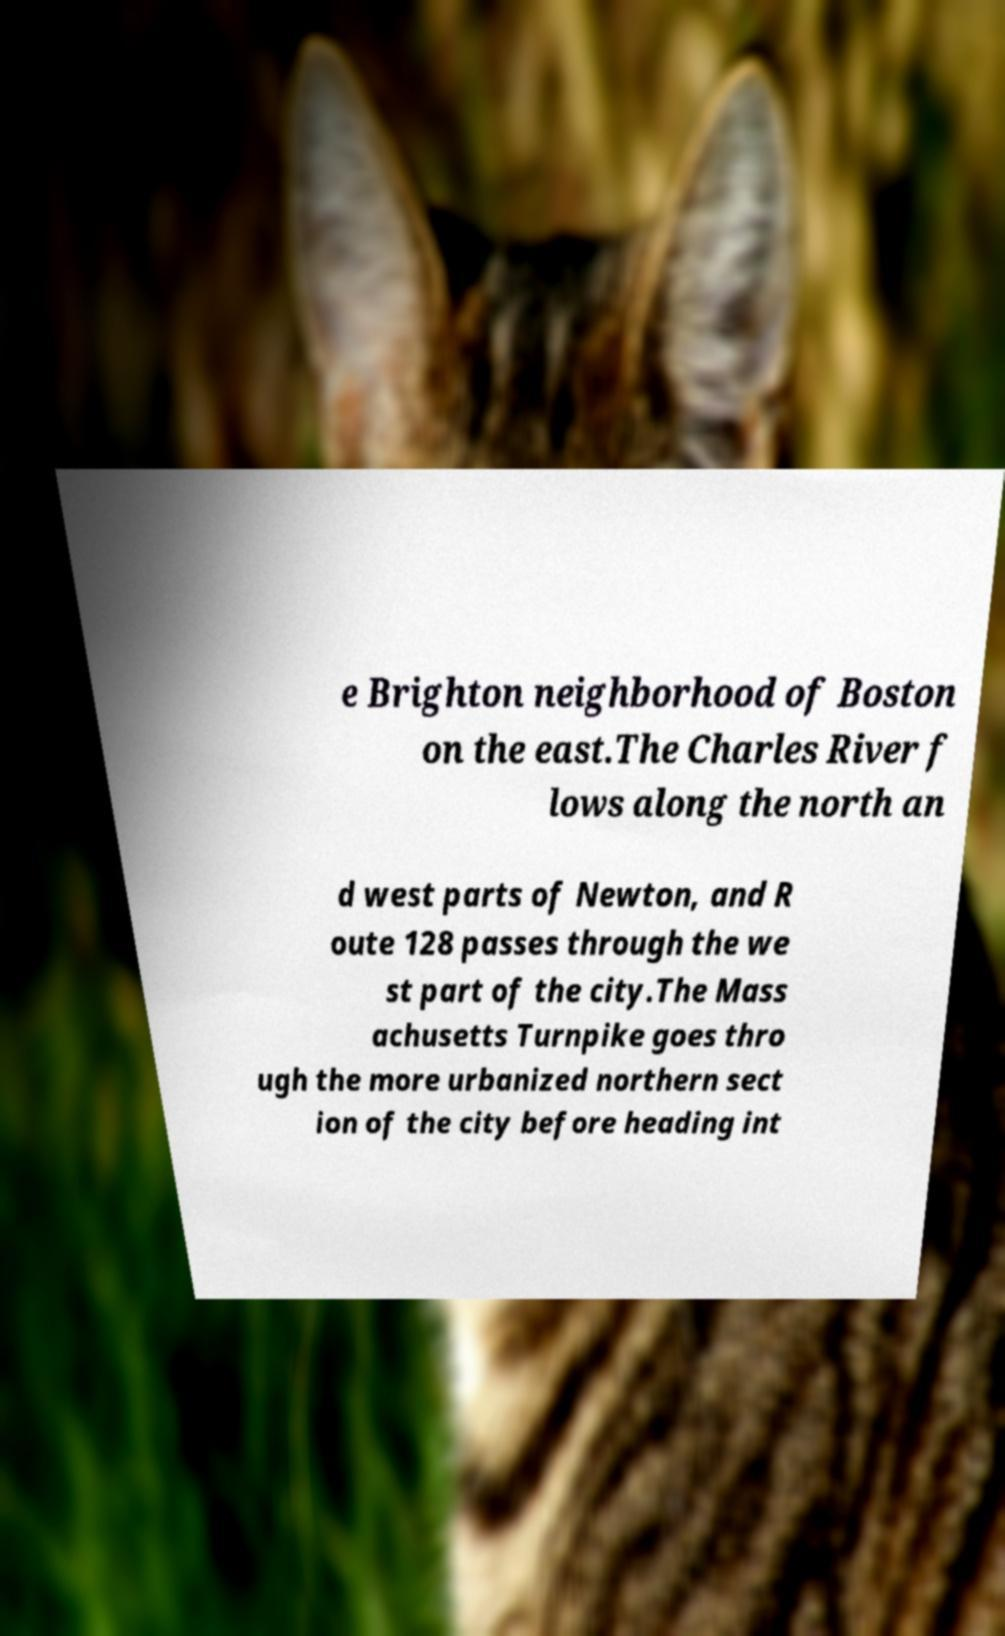Can you read and provide the text displayed in the image?This photo seems to have some interesting text. Can you extract and type it out for me? e Brighton neighborhood of Boston on the east.The Charles River f lows along the north an d west parts of Newton, and R oute 128 passes through the we st part of the city.The Mass achusetts Turnpike goes thro ugh the more urbanized northern sect ion of the city before heading int 